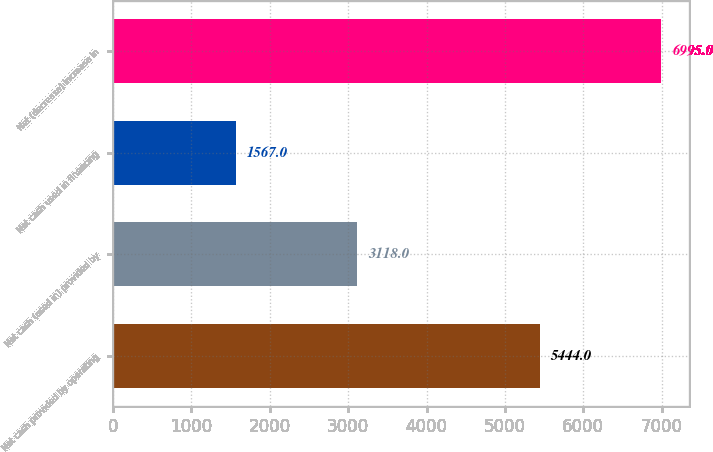Convert chart. <chart><loc_0><loc_0><loc_500><loc_500><bar_chart><fcel>Net cash provided by operating<fcel>Net cash (used in) provided by<fcel>Net cash used in financing<fcel>Net (decrease) increase in<nl><fcel>5444<fcel>3118<fcel>1567<fcel>6995<nl></chart> 